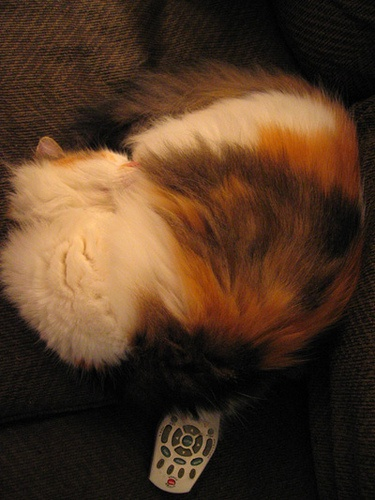Describe the objects in this image and their specific colors. I can see cat in black, maroon, tan, and brown tones, couch in black, maroon, and gray tones, and remote in black, gray, and maroon tones in this image. 